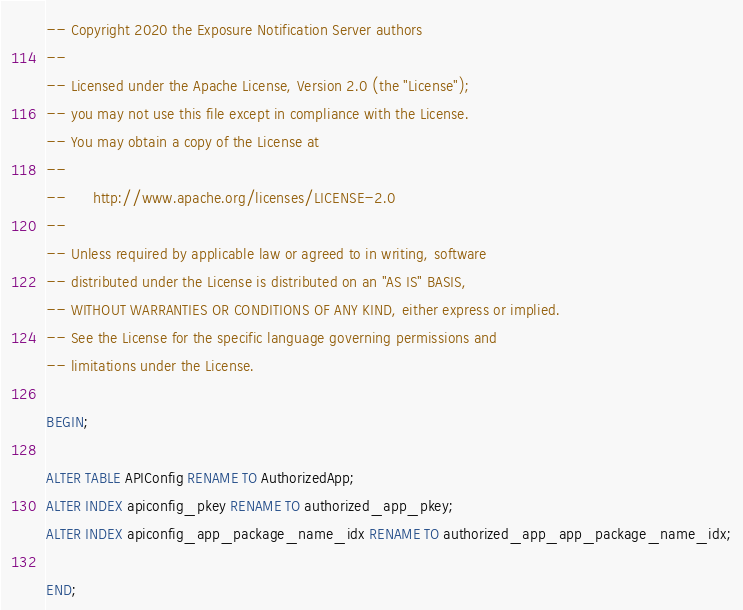<code> <loc_0><loc_0><loc_500><loc_500><_SQL_>-- Copyright 2020 the Exposure Notification Server authors
--
-- Licensed under the Apache License, Version 2.0 (the "License");
-- you may not use this file except in compliance with the License.
-- You may obtain a copy of the License at
--
--      http://www.apache.org/licenses/LICENSE-2.0
--
-- Unless required by applicable law or agreed to in writing, software
-- distributed under the License is distributed on an "AS IS" BASIS,
-- WITHOUT WARRANTIES OR CONDITIONS OF ANY KIND, either express or implied.
-- See the License for the specific language governing permissions and
-- limitations under the License.

BEGIN;

ALTER TABLE APIConfig RENAME TO AuthorizedApp;
ALTER INDEX apiconfig_pkey RENAME TO authorized_app_pkey;
ALTER INDEX apiconfig_app_package_name_idx RENAME TO authorized_app_app_package_name_idx;

END;
</code> 